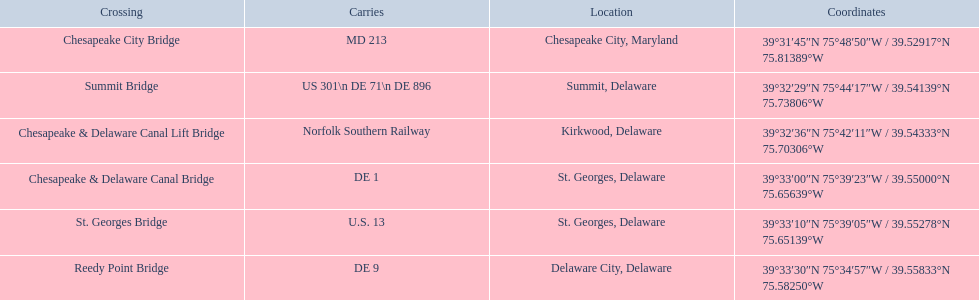Which are the bridges? Chesapeake City Bridge, Summit Bridge, Chesapeake & Delaware Canal Lift Bridge, Chesapeake & Delaware Canal Bridge, St. Georges Bridge, Reedy Point Bridge. Which are in delaware? Summit Bridge, Chesapeake & Delaware Canal Lift Bridge, Chesapeake & Delaware Canal Bridge, St. Georges Bridge, Reedy Point Bridge. Of these, which carries de 9? Reedy Point Bridge. 